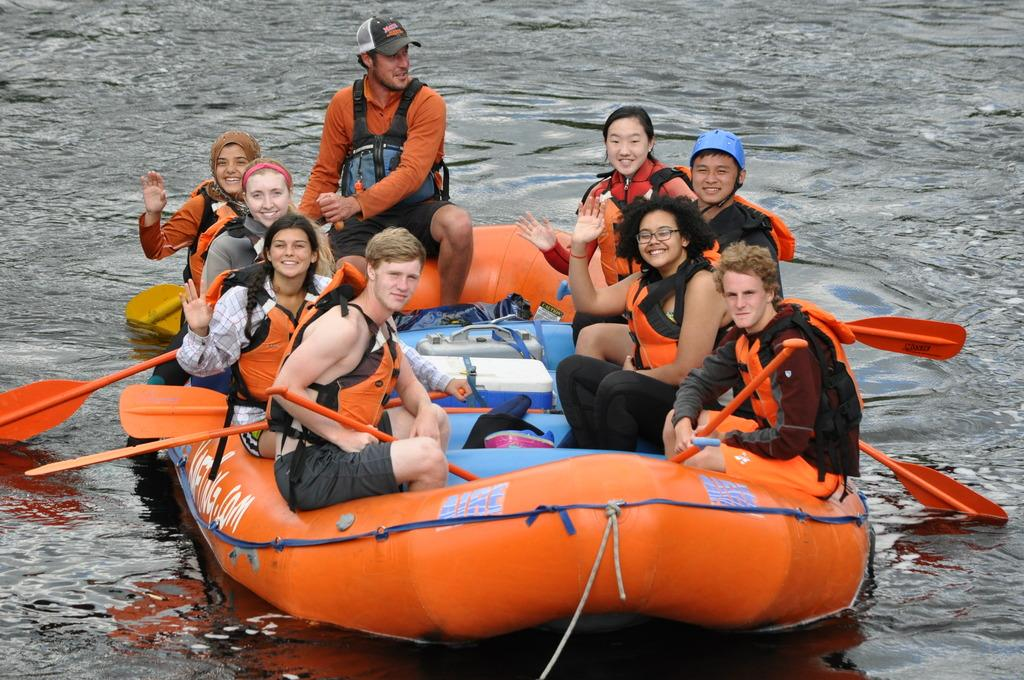What is the main subject of the picture? The main subject of the picture is a rafting boat. Who or what is inside the boat? There are people sitting in the boat. What can be seen in the background of the image? There is water visible in the background of the image. How does the boat increase its speed in the image? The image does not show the boat's speed increasing or decreasing; it only captures a moment in time. What is the end result of the rafting trip in the image? The image only shows a snapshot of the rafting trip and does not depict its end result. 